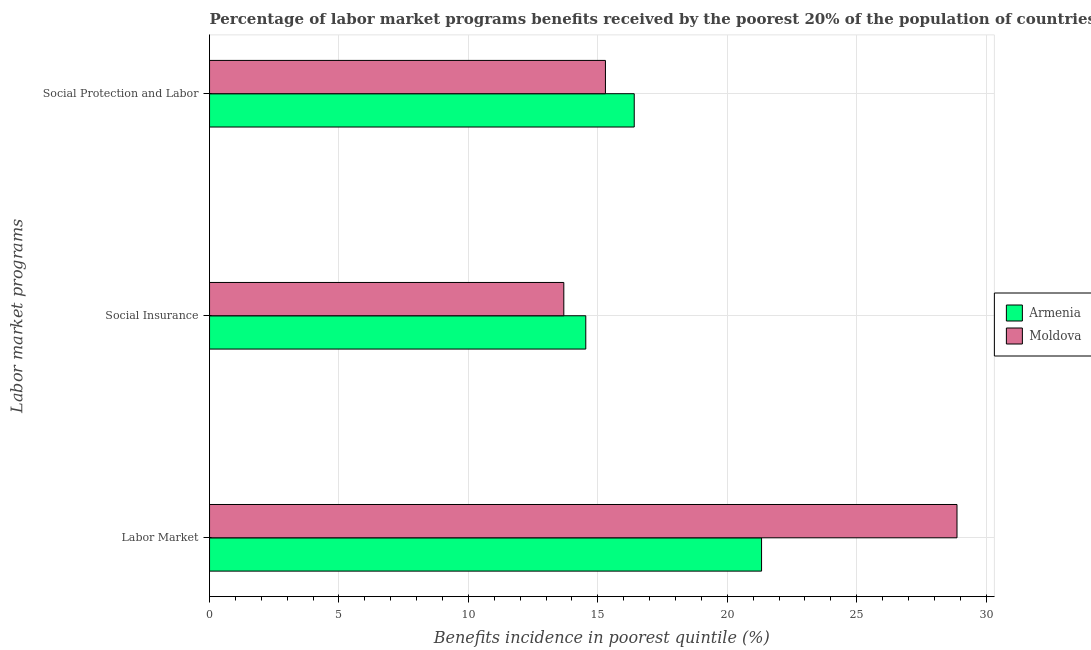Are the number of bars per tick equal to the number of legend labels?
Your answer should be very brief. Yes. Are the number of bars on each tick of the Y-axis equal?
Your answer should be compact. Yes. What is the label of the 2nd group of bars from the top?
Give a very brief answer. Social Insurance. What is the percentage of benefits received due to labor market programs in Armenia?
Your response must be concise. 21.33. Across all countries, what is the maximum percentage of benefits received due to labor market programs?
Offer a terse response. 28.88. Across all countries, what is the minimum percentage of benefits received due to labor market programs?
Keep it short and to the point. 21.33. In which country was the percentage of benefits received due to social insurance programs maximum?
Your answer should be compact. Armenia. In which country was the percentage of benefits received due to social protection programs minimum?
Your response must be concise. Moldova. What is the total percentage of benefits received due to social insurance programs in the graph?
Ensure brevity in your answer.  28.22. What is the difference between the percentage of benefits received due to social insurance programs in Moldova and that in Armenia?
Offer a very short reply. -0.85. What is the difference between the percentage of benefits received due to social insurance programs in Moldova and the percentage of benefits received due to social protection programs in Armenia?
Your answer should be compact. -2.72. What is the average percentage of benefits received due to social protection programs per country?
Keep it short and to the point. 15.85. What is the difference between the percentage of benefits received due to social insurance programs and percentage of benefits received due to social protection programs in Armenia?
Offer a terse response. -1.87. What is the ratio of the percentage of benefits received due to social protection programs in Moldova to that in Armenia?
Provide a short and direct response. 0.93. Is the difference between the percentage of benefits received due to labor market programs in Armenia and Moldova greater than the difference between the percentage of benefits received due to social protection programs in Armenia and Moldova?
Your response must be concise. No. What is the difference between the highest and the second highest percentage of benefits received due to labor market programs?
Give a very brief answer. 7.55. What is the difference between the highest and the lowest percentage of benefits received due to social insurance programs?
Make the answer very short. 0.85. Is the sum of the percentage of benefits received due to labor market programs in Moldova and Armenia greater than the maximum percentage of benefits received due to social protection programs across all countries?
Offer a terse response. Yes. What does the 2nd bar from the top in Social Insurance represents?
Offer a terse response. Armenia. What does the 2nd bar from the bottom in Social Insurance represents?
Provide a short and direct response. Moldova. How many bars are there?
Your answer should be compact. 6. Are all the bars in the graph horizontal?
Offer a very short reply. Yes. What is the difference between two consecutive major ticks on the X-axis?
Ensure brevity in your answer.  5. Are the values on the major ticks of X-axis written in scientific E-notation?
Your answer should be compact. No. How are the legend labels stacked?
Keep it short and to the point. Vertical. What is the title of the graph?
Provide a short and direct response. Percentage of labor market programs benefits received by the poorest 20% of the population of countries. Does "Latin America(developing only)" appear as one of the legend labels in the graph?
Give a very brief answer. No. What is the label or title of the X-axis?
Provide a succinct answer. Benefits incidence in poorest quintile (%). What is the label or title of the Y-axis?
Provide a short and direct response. Labor market programs. What is the Benefits incidence in poorest quintile (%) of Armenia in Labor Market?
Make the answer very short. 21.33. What is the Benefits incidence in poorest quintile (%) in Moldova in Labor Market?
Give a very brief answer. 28.88. What is the Benefits incidence in poorest quintile (%) in Armenia in Social Insurance?
Give a very brief answer. 14.54. What is the Benefits incidence in poorest quintile (%) of Moldova in Social Insurance?
Your answer should be compact. 13.69. What is the Benefits incidence in poorest quintile (%) of Armenia in Social Protection and Labor?
Make the answer very short. 16.41. What is the Benefits incidence in poorest quintile (%) of Moldova in Social Protection and Labor?
Provide a short and direct response. 15.29. Across all Labor market programs, what is the maximum Benefits incidence in poorest quintile (%) of Armenia?
Keep it short and to the point. 21.33. Across all Labor market programs, what is the maximum Benefits incidence in poorest quintile (%) in Moldova?
Ensure brevity in your answer.  28.88. Across all Labor market programs, what is the minimum Benefits incidence in poorest quintile (%) in Armenia?
Offer a terse response. 14.54. Across all Labor market programs, what is the minimum Benefits incidence in poorest quintile (%) in Moldova?
Keep it short and to the point. 13.69. What is the total Benefits incidence in poorest quintile (%) of Armenia in the graph?
Your answer should be very brief. 52.27. What is the total Benefits incidence in poorest quintile (%) in Moldova in the graph?
Provide a succinct answer. 57.86. What is the difference between the Benefits incidence in poorest quintile (%) in Armenia in Labor Market and that in Social Insurance?
Your response must be concise. 6.79. What is the difference between the Benefits incidence in poorest quintile (%) of Moldova in Labor Market and that in Social Insurance?
Make the answer very short. 15.19. What is the difference between the Benefits incidence in poorest quintile (%) in Armenia in Labor Market and that in Social Protection and Labor?
Give a very brief answer. 4.92. What is the difference between the Benefits incidence in poorest quintile (%) of Moldova in Labor Market and that in Social Protection and Labor?
Your answer should be compact. 13.58. What is the difference between the Benefits incidence in poorest quintile (%) in Armenia in Social Insurance and that in Social Protection and Labor?
Make the answer very short. -1.87. What is the difference between the Benefits incidence in poorest quintile (%) of Moldova in Social Insurance and that in Social Protection and Labor?
Ensure brevity in your answer.  -1.61. What is the difference between the Benefits incidence in poorest quintile (%) in Armenia in Labor Market and the Benefits incidence in poorest quintile (%) in Moldova in Social Insurance?
Offer a terse response. 7.64. What is the difference between the Benefits incidence in poorest quintile (%) in Armenia in Labor Market and the Benefits incidence in poorest quintile (%) in Moldova in Social Protection and Labor?
Your answer should be compact. 6.03. What is the difference between the Benefits incidence in poorest quintile (%) in Armenia in Social Insurance and the Benefits incidence in poorest quintile (%) in Moldova in Social Protection and Labor?
Your answer should be very brief. -0.76. What is the average Benefits incidence in poorest quintile (%) of Armenia per Labor market programs?
Your response must be concise. 17.42. What is the average Benefits incidence in poorest quintile (%) of Moldova per Labor market programs?
Offer a very short reply. 19.29. What is the difference between the Benefits incidence in poorest quintile (%) of Armenia and Benefits incidence in poorest quintile (%) of Moldova in Labor Market?
Your answer should be compact. -7.55. What is the difference between the Benefits incidence in poorest quintile (%) of Armenia and Benefits incidence in poorest quintile (%) of Moldova in Social Insurance?
Make the answer very short. 0.85. What is the difference between the Benefits incidence in poorest quintile (%) of Armenia and Benefits incidence in poorest quintile (%) of Moldova in Social Protection and Labor?
Your response must be concise. 1.11. What is the ratio of the Benefits incidence in poorest quintile (%) of Armenia in Labor Market to that in Social Insurance?
Offer a very short reply. 1.47. What is the ratio of the Benefits incidence in poorest quintile (%) of Moldova in Labor Market to that in Social Insurance?
Your answer should be very brief. 2.11. What is the ratio of the Benefits incidence in poorest quintile (%) of Armenia in Labor Market to that in Social Protection and Labor?
Ensure brevity in your answer.  1.3. What is the ratio of the Benefits incidence in poorest quintile (%) of Moldova in Labor Market to that in Social Protection and Labor?
Your answer should be compact. 1.89. What is the ratio of the Benefits incidence in poorest quintile (%) of Armenia in Social Insurance to that in Social Protection and Labor?
Give a very brief answer. 0.89. What is the ratio of the Benefits incidence in poorest quintile (%) of Moldova in Social Insurance to that in Social Protection and Labor?
Ensure brevity in your answer.  0.89. What is the difference between the highest and the second highest Benefits incidence in poorest quintile (%) in Armenia?
Your response must be concise. 4.92. What is the difference between the highest and the second highest Benefits incidence in poorest quintile (%) of Moldova?
Provide a short and direct response. 13.58. What is the difference between the highest and the lowest Benefits incidence in poorest quintile (%) of Armenia?
Provide a succinct answer. 6.79. What is the difference between the highest and the lowest Benefits incidence in poorest quintile (%) in Moldova?
Offer a very short reply. 15.19. 